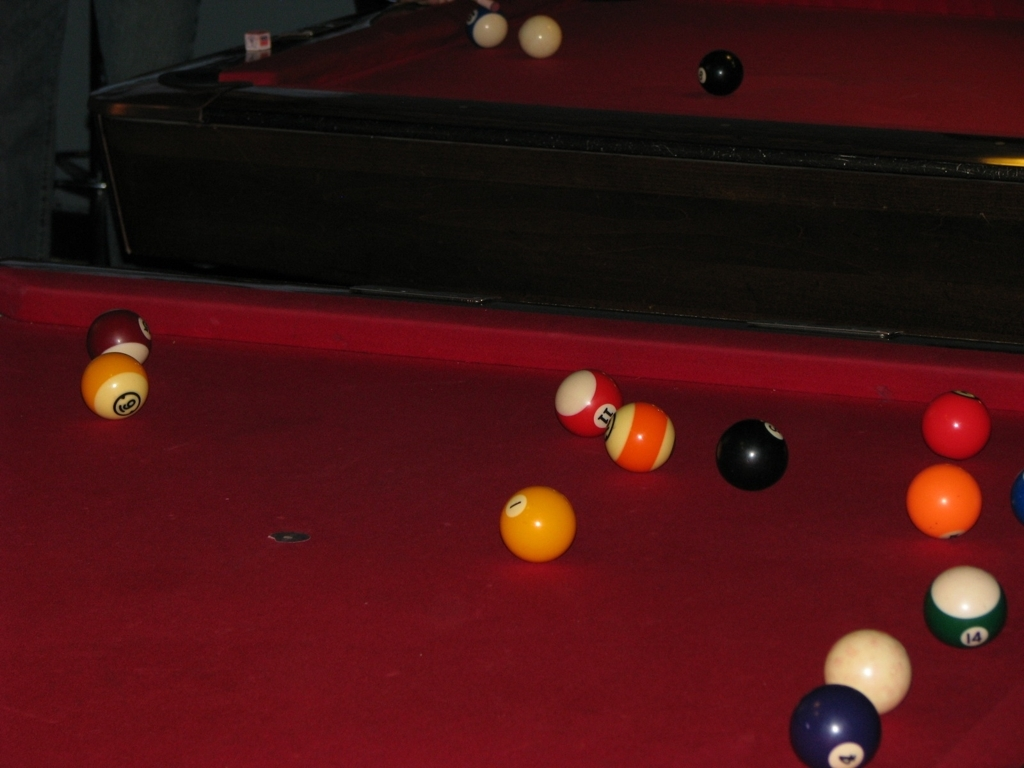What can you tell me about the activity present in this image? This image captures a game of pool in progress, as evidenced by the scattered billiard balls on the table. The cue ball's position, near the side pocket, suggests a recent shot. The game appears to be at an intermediate stage with both striped and solid balls remaining on the table. What mood does the image evoke? The warm undertones of the image and the soft lighting suggest a casual and relaxed environment, typical of social settings where pool is often played. The composition provides a sense of leisure and concentration, characterizing the mood as laid-back yet focused. 